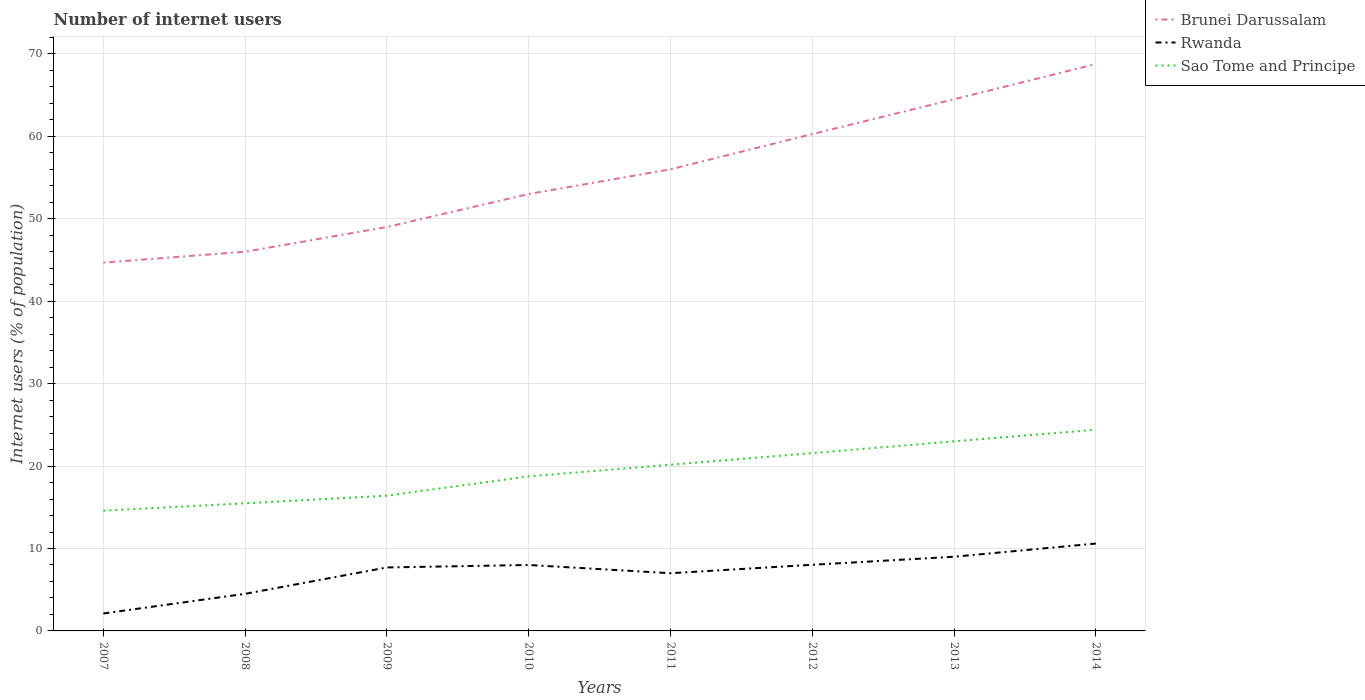How many different coloured lines are there?
Your response must be concise. 3. Does the line corresponding to Rwanda intersect with the line corresponding to Sao Tome and Principe?
Offer a terse response. No. Is the number of lines equal to the number of legend labels?
Ensure brevity in your answer.  Yes. Across all years, what is the maximum number of internet users in Brunei Darussalam?
Your response must be concise. 44.68. What is the difference between the highest and the second highest number of internet users in Sao Tome and Principe?
Provide a succinct answer. 9.82. How many lines are there?
Keep it short and to the point. 3. What is the difference between two consecutive major ticks on the Y-axis?
Your answer should be very brief. 10. How many legend labels are there?
Your answer should be compact. 3. What is the title of the graph?
Provide a succinct answer. Number of internet users. Does "Brazil" appear as one of the legend labels in the graph?
Your answer should be compact. No. What is the label or title of the Y-axis?
Provide a succinct answer. Internet users (% of population). What is the Internet users (% of population) in Brunei Darussalam in 2007?
Keep it short and to the point. 44.68. What is the Internet users (% of population) of Rwanda in 2007?
Provide a succinct answer. 2.12. What is the Internet users (% of population) in Sao Tome and Principe in 2007?
Provide a succinct answer. 14.59. What is the Internet users (% of population) in Brunei Darussalam in 2008?
Keep it short and to the point. 46. What is the Internet users (% of population) in Rwanda in 2008?
Make the answer very short. 4.5. What is the Internet users (% of population) of Sao Tome and Principe in 2008?
Your answer should be very brief. 15.48. What is the Internet users (% of population) of Brunei Darussalam in 2009?
Provide a succinct answer. 49. What is the Internet users (% of population) in Rwanda in 2009?
Your answer should be very brief. 7.7. What is the Internet users (% of population) in Sao Tome and Principe in 2009?
Provide a short and direct response. 16.41. What is the Internet users (% of population) in Brunei Darussalam in 2010?
Provide a short and direct response. 53. What is the Internet users (% of population) of Rwanda in 2010?
Ensure brevity in your answer.  8. What is the Internet users (% of population) of Sao Tome and Principe in 2010?
Your response must be concise. 18.75. What is the Internet users (% of population) of Sao Tome and Principe in 2011?
Offer a very short reply. 20.16. What is the Internet users (% of population) in Brunei Darussalam in 2012?
Make the answer very short. 60.27. What is the Internet users (% of population) in Rwanda in 2012?
Provide a succinct answer. 8.02. What is the Internet users (% of population) of Sao Tome and Principe in 2012?
Make the answer very short. 21.57. What is the Internet users (% of population) of Brunei Darussalam in 2013?
Offer a terse response. 64.5. What is the Internet users (% of population) in Brunei Darussalam in 2014?
Ensure brevity in your answer.  68.77. What is the Internet users (% of population) in Rwanda in 2014?
Make the answer very short. 10.6. What is the Internet users (% of population) of Sao Tome and Principe in 2014?
Your answer should be compact. 24.41. Across all years, what is the maximum Internet users (% of population) of Brunei Darussalam?
Give a very brief answer. 68.77. Across all years, what is the maximum Internet users (% of population) in Sao Tome and Principe?
Give a very brief answer. 24.41. Across all years, what is the minimum Internet users (% of population) of Brunei Darussalam?
Your response must be concise. 44.68. Across all years, what is the minimum Internet users (% of population) of Rwanda?
Your answer should be very brief. 2.12. Across all years, what is the minimum Internet users (% of population) of Sao Tome and Principe?
Your response must be concise. 14.59. What is the total Internet users (% of population) in Brunei Darussalam in the graph?
Keep it short and to the point. 442.22. What is the total Internet users (% of population) in Rwanda in the graph?
Give a very brief answer. 56.94. What is the total Internet users (% of population) in Sao Tome and Principe in the graph?
Offer a terse response. 154.37. What is the difference between the Internet users (% of population) of Brunei Darussalam in 2007 and that in 2008?
Keep it short and to the point. -1.32. What is the difference between the Internet users (% of population) in Rwanda in 2007 and that in 2008?
Your answer should be compact. -2.38. What is the difference between the Internet users (% of population) in Sao Tome and Principe in 2007 and that in 2008?
Offer a terse response. -0.89. What is the difference between the Internet users (% of population) in Brunei Darussalam in 2007 and that in 2009?
Offer a very short reply. -4.32. What is the difference between the Internet users (% of population) of Rwanda in 2007 and that in 2009?
Your response must be concise. -5.58. What is the difference between the Internet users (% of population) of Sao Tome and Principe in 2007 and that in 2009?
Your answer should be very brief. -1.82. What is the difference between the Internet users (% of population) of Brunei Darussalam in 2007 and that in 2010?
Offer a very short reply. -8.32. What is the difference between the Internet users (% of population) in Rwanda in 2007 and that in 2010?
Make the answer very short. -5.88. What is the difference between the Internet users (% of population) in Sao Tome and Principe in 2007 and that in 2010?
Give a very brief answer. -4.16. What is the difference between the Internet users (% of population) in Brunei Darussalam in 2007 and that in 2011?
Your response must be concise. -11.32. What is the difference between the Internet users (% of population) of Rwanda in 2007 and that in 2011?
Ensure brevity in your answer.  -4.88. What is the difference between the Internet users (% of population) of Sao Tome and Principe in 2007 and that in 2011?
Provide a succinct answer. -5.57. What is the difference between the Internet users (% of population) in Brunei Darussalam in 2007 and that in 2012?
Make the answer very short. -15.59. What is the difference between the Internet users (% of population) in Rwanda in 2007 and that in 2012?
Provide a succinct answer. -5.91. What is the difference between the Internet users (% of population) in Sao Tome and Principe in 2007 and that in 2012?
Offer a terse response. -6.98. What is the difference between the Internet users (% of population) of Brunei Darussalam in 2007 and that in 2013?
Provide a succinct answer. -19.82. What is the difference between the Internet users (% of population) in Rwanda in 2007 and that in 2013?
Offer a very short reply. -6.88. What is the difference between the Internet users (% of population) of Sao Tome and Principe in 2007 and that in 2013?
Keep it short and to the point. -8.41. What is the difference between the Internet users (% of population) in Brunei Darussalam in 2007 and that in 2014?
Ensure brevity in your answer.  -24.09. What is the difference between the Internet users (% of population) of Rwanda in 2007 and that in 2014?
Offer a very short reply. -8.48. What is the difference between the Internet users (% of population) of Sao Tome and Principe in 2007 and that in 2014?
Your answer should be compact. -9.82. What is the difference between the Internet users (% of population) of Sao Tome and Principe in 2008 and that in 2009?
Give a very brief answer. -0.93. What is the difference between the Internet users (% of population) in Brunei Darussalam in 2008 and that in 2010?
Your answer should be compact. -7. What is the difference between the Internet users (% of population) in Sao Tome and Principe in 2008 and that in 2010?
Provide a succinct answer. -3.27. What is the difference between the Internet users (% of population) of Rwanda in 2008 and that in 2011?
Your answer should be compact. -2.5. What is the difference between the Internet users (% of population) in Sao Tome and Principe in 2008 and that in 2011?
Ensure brevity in your answer.  -4.68. What is the difference between the Internet users (% of population) in Brunei Darussalam in 2008 and that in 2012?
Provide a succinct answer. -14.27. What is the difference between the Internet users (% of population) in Rwanda in 2008 and that in 2012?
Your answer should be very brief. -3.52. What is the difference between the Internet users (% of population) of Sao Tome and Principe in 2008 and that in 2012?
Keep it short and to the point. -6.09. What is the difference between the Internet users (% of population) of Brunei Darussalam in 2008 and that in 2013?
Make the answer very short. -18.5. What is the difference between the Internet users (% of population) of Rwanda in 2008 and that in 2013?
Your response must be concise. -4.5. What is the difference between the Internet users (% of population) of Sao Tome and Principe in 2008 and that in 2013?
Provide a short and direct response. -7.52. What is the difference between the Internet users (% of population) in Brunei Darussalam in 2008 and that in 2014?
Provide a short and direct response. -22.77. What is the difference between the Internet users (% of population) of Sao Tome and Principe in 2008 and that in 2014?
Provide a short and direct response. -8.93. What is the difference between the Internet users (% of population) in Brunei Darussalam in 2009 and that in 2010?
Offer a terse response. -4. What is the difference between the Internet users (% of population) of Rwanda in 2009 and that in 2010?
Your response must be concise. -0.3. What is the difference between the Internet users (% of population) in Sao Tome and Principe in 2009 and that in 2010?
Provide a short and direct response. -2.34. What is the difference between the Internet users (% of population) in Brunei Darussalam in 2009 and that in 2011?
Provide a succinct answer. -7. What is the difference between the Internet users (% of population) in Sao Tome and Principe in 2009 and that in 2011?
Your answer should be compact. -3.75. What is the difference between the Internet users (% of population) of Brunei Darussalam in 2009 and that in 2012?
Give a very brief answer. -11.27. What is the difference between the Internet users (% of population) in Rwanda in 2009 and that in 2012?
Offer a terse response. -0.32. What is the difference between the Internet users (% of population) of Sao Tome and Principe in 2009 and that in 2012?
Make the answer very short. -5.16. What is the difference between the Internet users (% of population) in Brunei Darussalam in 2009 and that in 2013?
Offer a very short reply. -15.5. What is the difference between the Internet users (% of population) in Sao Tome and Principe in 2009 and that in 2013?
Provide a short and direct response. -6.59. What is the difference between the Internet users (% of population) of Brunei Darussalam in 2009 and that in 2014?
Offer a very short reply. -19.77. What is the difference between the Internet users (% of population) in Rwanda in 2009 and that in 2014?
Your answer should be very brief. -2.9. What is the difference between the Internet users (% of population) in Brunei Darussalam in 2010 and that in 2011?
Offer a very short reply. -3. What is the difference between the Internet users (% of population) of Rwanda in 2010 and that in 2011?
Your answer should be very brief. 1. What is the difference between the Internet users (% of population) in Sao Tome and Principe in 2010 and that in 2011?
Provide a succinct answer. -1.41. What is the difference between the Internet users (% of population) in Brunei Darussalam in 2010 and that in 2012?
Give a very brief answer. -7.27. What is the difference between the Internet users (% of population) of Rwanda in 2010 and that in 2012?
Provide a short and direct response. -0.02. What is the difference between the Internet users (% of population) in Sao Tome and Principe in 2010 and that in 2012?
Offer a very short reply. -2.82. What is the difference between the Internet users (% of population) in Brunei Darussalam in 2010 and that in 2013?
Provide a short and direct response. -11.5. What is the difference between the Internet users (% of population) of Rwanda in 2010 and that in 2013?
Offer a very short reply. -1. What is the difference between the Internet users (% of population) of Sao Tome and Principe in 2010 and that in 2013?
Give a very brief answer. -4.25. What is the difference between the Internet users (% of population) in Brunei Darussalam in 2010 and that in 2014?
Keep it short and to the point. -15.77. What is the difference between the Internet users (% of population) of Sao Tome and Principe in 2010 and that in 2014?
Your answer should be compact. -5.66. What is the difference between the Internet users (% of population) in Brunei Darussalam in 2011 and that in 2012?
Your answer should be compact. -4.27. What is the difference between the Internet users (% of population) in Rwanda in 2011 and that in 2012?
Give a very brief answer. -1.02. What is the difference between the Internet users (% of population) in Sao Tome and Principe in 2011 and that in 2012?
Your response must be concise. -1.41. What is the difference between the Internet users (% of population) of Rwanda in 2011 and that in 2013?
Offer a very short reply. -2. What is the difference between the Internet users (% of population) in Sao Tome and Principe in 2011 and that in 2013?
Keep it short and to the point. -2.84. What is the difference between the Internet users (% of population) of Brunei Darussalam in 2011 and that in 2014?
Your answer should be very brief. -12.77. What is the difference between the Internet users (% of population) in Sao Tome and Principe in 2011 and that in 2014?
Ensure brevity in your answer.  -4.25. What is the difference between the Internet users (% of population) in Brunei Darussalam in 2012 and that in 2013?
Keep it short and to the point. -4.23. What is the difference between the Internet users (% of population) of Rwanda in 2012 and that in 2013?
Offer a very short reply. -0.98. What is the difference between the Internet users (% of population) in Sao Tome and Principe in 2012 and that in 2013?
Your answer should be compact. -1.43. What is the difference between the Internet users (% of population) in Brunei Darussalam in 2012 and that in 2014?
Offer a very short reply. -8.5. What is the difference between the Internet users (% of population) in Rwanda in 2012 and that in 2014?
Provide a succinct answer. -2.58. What is the difference between the Internet users (% of population) of Sao Tome and Principe in 2012 and that in 2014?
Make the answer very short. -2.84. What is the difference between the Internet users (% of population) of Brunei Darussalam in 2013 and that in 2014?
Provide a short and direct response. -4.27. What is the difference between the Internet users (% of population) in Sao Tome and Principe in 2013 and that in 2014?
Provide a short and direct response. -1.41. What is the difference between the Internet users (% of population) in Brunei Darussalam in 2007 and the Internet users (% of population) in Rwanda in 2008?
Your answer should be compact. 40.18. What is the difference between the Internet users (% of population) in Brunei Darussalam in 2007 and the Internet users (% of population) in Sao Tome and Principe in 2008?
Your answer should be compact. 29.2. What is the difference between the Internet users (% of population) of Rwanda in 2007 and the Internet users (% of population) of Sao Tome and Principe in 2008?
Provide a succinct answer. -13.36. What is the difference between the Internet users (% of population) of Brunei Darussalam in 2007 and the Internet users (% of population) of Rwanda in 2009?
Your answer should be compact. 36.98. What is the difference between the Internet users (% of population) in Brunei Darussalam in 2007 and the Internet users (% of population) in Sao Tome and Principe in 2009?
Your answer should be very brief. 28.27. What is the difference between the Internet users (% of population) in Rwanda in 2007 and the Internet users (% of population) in Sao Tome and Principe in 2009?
Provide a succinct answer. -14.29. What is the difference between the Internet users (% of population) of Brunei Darussalam in 2007 and the Internet users (% of population) of Rwanda in 2010?
Your answer should be very brief. 36.68. What is the difference between the Internet users (% of population) in Brunei Darussalam in 2007 and the Internet users (% of population) in Sao Tome and Principe in 2010?
Keep it short and to the point. 25.93. What is the difference between the Internet users (% of population) in Rwanda in 2007 and the Internet users (% of population) in Sao Tome and Principe in 2010?
Give a very brief answer. -16.63. What is the difference between the Internet users (% of population) in Brunei Darussalam in 2007 and the Internet users (% of population) in Rwanda in 2011?
Your response must be concise. 37.68. What is the difference between the Internet users (% of population) in Brunei Darussalam in 2007 and the Internet users (% of population) in Sao Tome and Principe in 2011?
Your response must be concise. 24.52. What is the difference between the Internet users (% of population) of Rwanda in 2007 and the Internet users (% of population) of Sao Tome and Principe in 2011?
Your answer should be compact. -18.05. What is the difference between the Internet users (% of population) of Brunei Darussalam in 2007 and the Internet users (% of population) of Rwanda in 2012?
Your answer should be very brief. 36.66. What is the difference between the Internet users (% of population) of Brunei Darussalam in 2007 and the Internet users (% of population) of Sao Tome and Principe in 2012?
Your answer should be compact. 23.11. What is the difference between the Internet users (% of population) in Rwanda in 2007 and the Internet users (% of population) in Sao Tome and Principe in 2012?
Offer a terse response. -19.46. What is the difference between the Internet users (% of population) of Brunei Darussalam in 2007 and the Internet users (% of population) of Rwanda in 2013?
Provide a short and direct response. 35.68. What is the difference between the Internet users (% of population) of Brunei Darussalam in 2007 and the Internet users (% of population) of Sao Tome and Principe in 2013?
Make the answer very short. 21.68. What is the difference between the Internet users (% of population) in Rwanda in 2007 and the Internet users (% of population) in Sao Tome and Principe in 2013?
Make the answer very short. -20.88. What is the difference between the Internet users (% of population) of Brunei Darussalam in 2007 and the Internet users (% of population) of Rwanda in 2014?
Your answer should be very brief. 34.08. What is the difference between the Internet users (% of population) in Brunei Darussalam in 2007 and the Internet users (% of population) in Sao Tome and Principe in 2014?
Provide a short and direct response. 20.27. What is the difference between the Internet users (% of population) in Rwanda in 2007 and the Internet users (% of population) in Sao Tome and Principe in 2014?
Offer a terse response. -22.29. What is the difference between the Internet users (% of population) of Brunei Darussalam in 2008 and the Internet users (% of population) of Rwanda in 2009?
Give a very brief answer. 38.3. What is the difference between the Internet users (% of population) of Brunei Darussalam in 2008 and the Internet users (% of population) of Sao Tome and Principe in 2009?
Make the answer very short. 29.59. What is the difference between the Internet users (% of population) of Rwanda in 2008 and the Internet users (% of population) of Sao Tome and Principe in 2009?
Make the answer very short. -11.91. What is the difference between the Internet users (% of population) of Brunei Darussalam in 2008 and the Internet users (% of population) of Sao Tome and Principe in 2010?
Provide a short and direct response. 27.25. What is the difference between the Internet users (% of population) in Rwanda in 2008 and the Internet users (% of population) in Sao Tome and Principe in 2010?
Ensure brevity in your answer.  -14.25. What is the difference between the Internet users (% of population) in Brunei Darussalam in 2008 and the Internet users (% of population) in Sao Tome and Principe in 2011?
Make the answer very short. 25.84. What is the difference between the Internet users (% of population) of Rwanda in 2008 and the Internet users (% of population) of Sao Tome and Principe in 2011?
Offer a terse response. -15.66. What is the difference between the Internet users (% of population) of Brunei Darussalam in 2008 and the Internet users (% of population) of Rwanda in 2012?
Ensure brevity in your answer.  37.98. What is the difference between the Internet users (% of population) in Brunei Darussalam in 2008 and the Internet users (% of population) in Sao Tome and Principe in 2012?
Your response must be concise. 24.43. What is the difference between the Internet users (% of population) of Rwanda in 2008 and the Internet users (% of population) of Sao Tome and Principe in 2012?
Your answer should be compact. -17.07. What is the difference between the Internet users (% of population) of Brunei Darussalam in 2008 and the Internet users (% of population) of Sao Tome and Principe in 2013?
Your answer should be compact. 23. What is the difference between the Internet users (% of population) of Rwanda in 2008 and the Internet users (% of population) of Sao Tome and Principe in 2013?
Provide a short and direct response. -18.5. What is the difference between the Internet users (% of population) of Brunei Darussalam in 2008 and the Internet users (% of population) of Rwanda in 2014?
Your answer should be compact. 35.4. What is the difference between the Internet users (% of population) of Brunei Darussalam in 2008 and the Internet users (% of population) of Sao Tome and Principe in 2014?
Keep it short and to the point. 21.59. What is the difference between the Internet users (% of population) of Rwanda in 2008 and the Internet users (% of population) of Sao Tome and Principe in 2014?
Your answer should be very brief. -19.91. What is the difference between the Internet users (% of population) of Brunei Darussalam in 2009 and the Internet users (% of population) of Sao Tome and Principe in 2010?
Offer a very short reply. 30.25. What is the difference between the Internet users (% of population) in Rwanda in 2009 and the Internet users (% of population) in Sao Tome and Principe in 2010?
Offer a terse response. -11.05. What is the difference between the Internet users (% of population) in Brunei Darussalam in 2009 and the Internet users (% of population) in Rwanda in 2011?
Offer a terse response. 42. What is the difference between the Internet users (% of population) in Brunei Darussalam in 2009 and the Internet users (% of population) in Sao Tome and Principe in 2011?
Make the answer very short. 28.84. What is the difference between the Internet users (% of population) in Rwanda in 2009 and the Internet users (% of population) in Sao Tome and Principe in 2011?
Your answer should be compact. -12.46. What is the difference between the Internet users (% of population) of Brunei Darussalam in 2009 and the Internet users (% of population) of Rwanda in 2012?
Provide a succinct answer. 40.98. What is the difference between the Internet users (% of population) in Brunei Darussalam in 2009 and the Internet users (% of population) in Sao Tome and Principe in 2012?
Offer a very short reply. 27.43. What is the difference between the Internet users (% of population) in Rwanda in 2009 and the Internet users (% of population) in Sao Tome and Principe in 2012?
Make the answer very short. -13.87. What is the difference between the Internet users (% of population) in Brunei Darussalam in 2009 and the Internet users (% of population) in Sao Tome and Principe in 2013?
Make the answer very short. 26. What is the difference between the Internet users (% of population) in Rwanda in 2009 and the Internet users (% of population) in Sao Tome and Principe in 2013?
Ensure brevity in your answer.  -15.3. What is the difference between the Internet users (% of population) in Brunei Darussalam in 2009 and the Internet users (% of population) in Rwanda in 2014?
Give a very brief answer. 38.4. What is the difference between the Internet users (% of population) of Brunei Darussalam in 2009 and the Internet users (% of population) of Sao Tome and Principe in 2014?
Provide a short and direct response. 24.59. What is the difference between the Internet users (% of population) of Rwanda in 2009 and the Internet users (% of population) of Sao Tome and Principe in 2014?
Your response must be concise. -16.71. What is the difference between the Internet users (% of population) in Brunei Darussalam in 2010 and the Internet users (% of population) in Rwanda in 2011?
Keep it short and to the point. 46. What is the difference between the Internet users (% of population) of Brunei Darussalam in 2010 and the Internet users (% of population) of Sao Tome and Principe in 2011?
Your answer should be very brief. 32.84. What is the difference between the Internet users (% of population) of Rwanda in 2010 and the Internet users (% of population) of Sao Tome and Principe in 2011?
Your answer should be compact. -12.16. What is the difference between the Internet users (% of population) in Brunei Darussalam in 2010 and the Internet users (% of population) in Rwanda in 2012?
Offer a very short reply. 44.98. What is the difference between the Internet users (% of population) in Brunei Darussalam in 2010 and the Internet users (% of population) in Sao Tome and Principe in 2012?
Ensure brevity in your answer.  31.43. What is the difference between the Internet users (% of population) of Rwanda in 2010 and the Internet users (% of population) of Sao Tome and Principe in 2012?
Provide a succinct answer. -13.57. What is the difference between the Internet users (% of population) in Brunei Darussalam in 2010 and the Internet users (% of population) in Sao Tome and Principe in 2013?
Provide a succinct answer. 30. What is the difference between the Internet users (% of population) of Brunei Darussalam in 2010 and the Internet users (% of population) of Rwanda in 2014?
Your answer should be very brief. 42.4. What is the difference between the Internet users (% of population) in Brunei Darussalam in 2010 and the Internet users (% of population) in Sao Tome and Principe in 2014?
Make the answer very short. 28.59. What is the difference between the Internet users (% of population) in Rwanda in 2010 and the Internet users (% of population) in Sao Tome and Principe in 2014?
Offer a very short reply. -16.41. What is the difference between the Internet users (% of population) in Brunei Darussalam in 2011 and the Internet users (% of population) in Rwanda in 2012?
Provide a short and direct response. 47.98. What is the difference between the Internet users (% of population) in Brunei Darussalam in 2011 and the Internet users (% of population) in Sao Tome and Principe in 2012?
Your response must be concise. 34.43. What is the difference between the Internet users (% of population) of Rwanda in 2011 and the Internet users (% of population) of Sao Tome and Principe in 2012?
Make the answer very short. -14.57. What is the difference between the Internet users (% of population) in Brunei Darussalam in 2011 and the Internet users (% of population) in Rwanda in 2013?
Your response must be concise. 47. What is the difference between the Internet users (% of population) in Brunei Darussalam in 2011 and the Internet users (% of population) in Sao Tome and Principe in 2013?
Your response must be concise. 33. What is the difference between the Internet users (% of population) in Rwanda in 2011 and the Internet users (% of population) in Sao Tome and Principe in 2013?
Provide a short and direct response. -16. What is the difference between the Internet users (% of population) in Brunei Darussalam in 2011 and the Internet users (% of population) in Rwanda in 2014?
Offer a very short reply. 45.4. What is the difference between the Internet users (% of population) in Brunei Darussalam in 2011 and the Internet users (% of population) in Sao Tome and Principe in 2014?
Your response must be concise. 31.59. What is the difference between the Internet users (% of population) of Rwanda in 2011 and the Internet users (% of population) of Sao Tome and Principe in 2014?
Give a very brief answer. -17.41. What is the difference between the Internet users (% of population) of Brunei Darussalam in 2012 and the Internet users (% of population) of Rwanda in 2013?
Provide a succinct answer. 51.27. What is the difference between the Internet users (% of population) of Brunei Darussalam in 2012 and the Internet users (% of population) of Sao Tome and Principe in 2013?
Provide a succinct answer. 37.27. What is the difference between the Internet users (% of population) of Rwanda in 2012 and the Internet users (% of population) of Sao Tome and Principe in 2013?
Offer a terse response. -14.98. What is the difference between the Internet users (% of population) of Brunei Darussalam in 2012 and the Internet users (% of population) of Rwanda in 2014?
Make the answer very short. 49.67. What is the difference between the Internet users (% of population) of Brunei Darussalam in 2012 and the Internet users (% of population) of Sao Tome and Principe in 2014?
Ensure brevity in your answer.  35.86. What is the difference between the Internet users (% of population) in Rwanda in 2012 and the Internet users (% of population) in Sao Tome and Principe in 2014?
Your answer should be very brief. -16.39. What is the difference between the Internet users (% of population) of Brunei Darussalam in 2013 and the Internet users (% of population) of Rwanda in 2014?
Ensure brevity in your answer.  53.9. What is the difference between the Internet users (% of population) in Brunei Darussalam in 2013 and the Internet users (% of population) in Sao Tome and Principe in 2014?
Your answer should be compact. 40.09. What is the difference between the Internet users (% of population) of Rwanda in 2013 and the Internet users (% of population) of Sao Tome and Principe in 2014?
Ensure brevity in your answer.  -15.41. What is the average Internet users (% of population) in Brunei Darussalam per year?
Provide a short and direct response. 55.28. What is the average Internet users (% of population) of Rwanda per year?
Make the answer very short. 7.12. What is the average Internet users (% of population) in Sao Tome and Principe per year?
Offer a very short reply. 19.3. In the year 2007, what is the difference between the Internet users (% of population) of Brunei Darussalam and Internet users (% of population) of Rwanda?
Offer a very short reply. 42.56. In the year 2007, what is the difference between the Internet users (% of population) in Brunei Darussalam and Internet users (% of population) in Sao Tome and Principe?
Your answer should be compact. 30.09. In the year 2007, what is the difference between the Internet users (% of population) of Rwanda and Internet users (% of population) of Sao Tome and Principe?
Make the answer very short. -12.48. In the year 2008, what is the difference between the Internet users (% of population) in Brunei Darussalam and Internet users (% of population) in Rwanda?
Provide a succinct answer. 41.5. In the year 2008, what is the difference between the Internet users (% of population) of Brunei Darussalam and Internet users (% of population) of Sao Tome and Principe?
Your response must be concise. 30.52. In the year 2008, what is the difference between the Internet users (% of population) of Rwanda and Internet users (% of population) of Sao Tome and Principe?
Your response must be concise. -10.98. In the year 2009, what is the difference between the Internet users (% of population) in Brunei Darussalam and Internet users (% of population) in Rwanda?
Offer a terse response. 41.3. In the year 2009, what is the difference between the Internet users (% of population) in Brunei Darussalam and Internet users (% of population) in Sao Tome and Principe?
Your answer should be compact. 32.59. In the year 2009, what is the difference between the Internet users (% of population) in Rwanda and Internet users (% of population) in Sao Tome and Principe?
Keep it short and to the point. -8.71. In the year 2010, what is the difference between the Internet users (% of population) in Brunei Darussalam and Internet users (% of population) in Rwanda?
Make the answer very short. 45. In the year 2010, what is the difference between the Internet users (% of population) in Brunei Darussalam and Internet users (% of population) in Sao Tome and Principe?
Offer a terse response. 34.25. In the year 2010, what is the difference between the Internet users (% of population) of Rwanda and Internet users (% of population) of Sao Tome and Principe?
Provide a short and direct response. -10.75. In the year 2011, what is the difference between the Internet users (% of population) in Brunei Darussalam and Internet users (% of population) in Rwanda?
Make the answer very short. 49. In the year 2011, what is the difference between the Internet users (% of population) of Brunei Darussalam and Internet users (% of population) of Sao Tome and Principe?
Your answer should be very brief. 35.84. In the year 2011, what is the difference between the Internet users (% of population) in Rwanda and Internet users (% of population) in Sao Tome and Principe?
Make the answer very short. -13.16. In the year 2012, what is the difference between the Internet users (% of population) in Brunei Darussalam and Internet users (% of population) in Rwanda?
Offer a terse response. 52.25. In the year 2012, what is the difference between the Internet users (% of population) of Brunei Darussalam and Internet users (% of population) of Sao Tome and Principe?
Ensure brevity in your answer.  38.7. In the year 2012, what is the difference between the Internet users (% of population) in Rwanda and Internet users (% of population) in Sao Tome and Principe?
Your answer should be compact. -13.55. In the year 2013, what is the difference between the Internet users (% of population) in Brunei Darussalam and Internet users (% of population) in Rwanda?
Offer a very short reply. 55.5. In the year 2013, what is the difference between the Internet users (% of population) of Brunei Darussalam and Internet users (% of population) of Sao Tome and Principe?
Provide a succinct answer. 41.5. In the year 2014, what is the difference between the Internet users (% of population) in Brunei Darussalam and Internet users (% of population) in Rwanda?
Offer a terse response. 58.17. In the year 2014, what is the difference between the Internet users (% of population) in Brunei Darussalam and Internet users (% of population) in Sao Tome and Principe?
Your answer should be compact. 44.36. In the year 2014, what is the difference between the Internet users (% of population) of Rwanda and Internet users (% of population) of Sao Tome and Principe?
Ensure brevity in your answer.  -13.81. What is the ratio of the Internet users (% of population) in Brunei Darussalam in 2007 to that in 2008?
Keep it short and to the point. 0.97. What is the ratio of the Internet users (% of population) in Rwanda in 2007 to that in 2008?
Your response must be concise. 0.47. What is the ratio of the Internet users (% of population) of Sao Tome and Principe in 2007 to that in 2008?
Provide a short and direct response. 0.94. What is the ratio of the Internet users (% of population) of Brunei Darussalam in 2007 to that in 2009?
Keep it short and to the point. 0.91. What is the ratio of the Internet users (% of population) in Rwanda in 2007 to that in 2009?
Provide a short and direct response. 0.27. What is the ratio of the Internet users (% of population) of Sao Tome and Principe in 2007 to that in 2009?
Ensure brevity in your answer.  0.89. What is the ratio of the Internet users (% of population) of Brunei Darussalam in 2007 to that in 2010?
Ensure brevity in your answer.  0.84. What is the ratio of the Internet users (% of population) of Rwanda in 2007 to that in 2010?
Your answer should be very brief. 0.26. What is the ratio of the Internet users (% of population) in Sao Tome and Principe in 2007 to that in 2010?
Your answer should be very brief. 0.78. What is the ratio of the Internet users (% of population) in Brunei Darussalam in 2007 to that in 2011?
Provide a short and direct response. 0.8. What is the ratio of the Internet users (% of population) of Rwanda in 2007 to that in 2011?
Provide a short and direct response. 0.3. What is the ratio of the Internet users (% of population) of Sao Tome and Principe in 2007 to that in 2011?
Provide a short and direct response. 0.72. What is the ratio of the Internet users (% of population) in Brunei Darussalam in 2007 to that in 2012?
Your answer should be compact. 0.74. What is the ratio of the Internet users (% of population) of Rwanda in 2007 to that in 2012?
Your response must be concise. 0.26. What is the ratio of the Internet users (% of population) in Sao Tome and Principe in 2007 to that in 2012?
Provide a succinct answer. 0.68. What is the ratio of the Internet users (% of population) in Brunei Darussalam in 2007 to that in 2013?
Your answer should be very brief. 0.69. What is the ratio of the Internet users (% of population) in Rwanda in 2007 to that in 2013?
Your response must be concise. 0.23. What is the ratio of the Internet users (% of population) in Sao Tome and Principe in 2007 to that in 2013?
Give a very brief answer. 0.63. What is the ratio of the Internet users (% of population) in Brunei Darussalam in 2007 to that in 2014?
Provide a short and direct response. 0.65. What is the ratio of the Internet users (% of population) in Rwanda in 2007 to that in 2014?
Give a very brief answer. 0.2. What is the ratio of the Internet users (% of population) of Sao Tome and Principe in 2007 to that in 2014?
Keep it short and to the point. 0.6. What is the ratio of the Internet users (% of population) in Brunei Darussalam in 2008 to that in 2009?
Offer a very short reply. 0.94. What is the ratio of the Internet users (% of population) of Rwanda in 2008 to that in 2009?
Provide a succinct answer. 0.58. What is the ratio of the Internet users (% of population) in Sao Tome and Principe in 2008 to that in 2009?
Provide a short and direct response. 0.94. What is the ratio of the Internet users (% of population) of Brunei Darussalam in 2008 to that in 2010?
Provide a succinct answer. 0.87. What is the ratio of the Internet users (% of population) in Rwanda in 2008 to that in 2010?
Your answer should be very brief. 0.56. What is the ratio of the Internet users (% of population) in Sao Tome and Principe in 2008 to that in 2010?
Ensure brevity in your answer.  0.83. What is the ratio of the Internet users (% of population) of Brunei Darussalam in 2008 to that in 2011?
Your answer should be very brief. 0.82. What is the ratio of the Internet users (% of population) of Rwanda in 2008 to that in 2011?
Your answer should be very brief. 0.64. What is the ratio of the Internet users (% of population) of Sao Tome and Principe in 2008 to that in 2011?
Offer a very short reply. 0.77. What is the ratio of the Internet users (% of population) in Brunei Darussalam in 2008 to that in 2012?
Keep it short and to the point. 0.76. What is the ratio of the Internet users (% of population) of Rwanda in 2008 to that in 2012?
Your answer should be compact. 0.56. What is the ratio of the Internet users (% of population) in Sao Tome and Principe in 2008 to that in 2012?
Provide a succinct answer. 0.72. What is the ratio of the Internet users (% of population) of Brunei Darussalam in 2008 to that in 2013?
Provide a succinct answer. 0.71. What is the ratio of the Internet users (% of population) of Rwanda in 2008 to that in 2013?
Your answer should be very brief. 0.5. What is the ratio of the Internet users (% of population) of Sao Tome and Principe in 2008 to that in 2013?
Your response must be concise. 0.67. What is the ratio of the Internet users (% of population) in Brunei Darussalam in 2008 to that in 2014?
Give a very brief answer. 0.67. What is the ratio of the Internet users (% of population) in Rwanda in 2008 to that in 2014?
Your answer should be compact. 0.42. What is the ratio of the Internet users (% of population) of Sao Tome and Principe in 2008 to that in 2014?
Offer a terse response. 0.63. What is the ratio of the Internet users (% of population) of Brunei Darussalam in 2009 to that in 2010?
Make the answer very short. 0.92. What is the ratio of the Internet users (% of population) in Rwanda in 2009 to that in 2010?
Give a very brief answer. 0.96. What is the ratio of the Internet users (% of population) in Sao Tome and Principe in 2009 to that in 2010?
Keep it short and to the point. 0.88. What is the ratio of the Internet users (% of population) in Sao Tome and Principe in 2009 to that in 2011?
Your answer should be very brief. 0.81. What is the ratio of the Internet users (% of population) of Brunei Darussalam in 2009 to that in 2012?
Ensure brevity in your answer.  0.81. What is the ratio of the Internet users (% of population) of Rwanda in 2009 to that in 2012?
Your response must be concise. 0.96. What is the ratio of the Internet users (% of population) of Sao Tome and Principe in 2009 to that in 2012?
Offer a very short reply. 0.76. What is the ratio of the Internet users (% of population) in Brunei Darussalam in 2009 to that in 2013?
Your answer should be very brief. 0.76. What is the ratio of the Internet users (% of population) of Rwanda in 2009 to that in 2013?
Offer a very short reply. 0.86. What is the ratio of the Internet users (% of population) in Sao Tome and Principe in 2009 to that in 2013?
Provide a short and direct response. 0.71. What is the ratio of the Internet users (% of population) of Brunei Darussalam in 2009 to that in 2014?
Provide a succinct answer. 0.71. What is the ratio of the Internet users (% of population) of Rwanda in 2009 to that in 2014?
Your response must be concise. 0.73. What is the ratio of the Internet users (% of population) of Sao Tome and Principe in 2009 to that in 2014?
Give a very brief answer. 0.67. What is the ratio of the Internet users (% of population) in Brunei Darussalam in 2010 to that in 2011?
Make the answer very short. 0.95. What is the ratio of the Internet users (% of population) of Rwanda in 2010 to that in 2011?
Ensure brevity in your answer.  1.14. What is the ratio of the Internet users (% of population) in Sao Tome and Principe in 2010 to that in 2011?
Give a very brief answer. 0.93. What is the ratio of the Internet users (% of population) of Brunei Darussalam in 2010 to that in 2012?
Your answer should be compact. 0.88. What is the ratio of the Internet users (% of population) of Rwanda in 2010 to that in 2012?
Keep it short and to the point. 1. What is the ratio of the Internet users (% of population) of Sao Tome and Principe in 2010 to that in 2012?
Offer a very short reply. 0.87. What is the ratio of the Internet users (% of population) of Brunei Darussalam in 2010 to that in 2013?
Give a very brief answer. 0.82. What is the ratio of the Internet users (% of population) of Rwanda in 2010 to that in 2013?
Your answer should be compact. 0.89. What is the ratio of the Internet users (% of population) of Sao Tome and Principe in 2010 to that in 2013?
Make the answer very short. 0.82. What is the ratio of the Internet users (% of population) in Brunei Darussalam in 2010 to that in 2014?
Provide a succinct answer. 0.77. What is the ratio of the Internet users (% of population) in Rwanda in 2010 to that in 2014?
Your answer should be compact. 0.75. What is the ratio of the Internet users (% of population) in Sao Tome and Principe in 2010 to that in 2014?
Provide a short and direct response. 0.77. What is the ratio of the Internet users (% of population) of Brunei Darussalam in 2011 to that in 2012?
Keep it short and to the point. 0.93. What is the ratio of the Internet users (% of population) in Rwanda in 2011 to that in 2012?
Make the answer very short. 0.87. What is the ratio of the Internet users (% of population) of Sao Tome and Principe in 2011 to that in 2012?
Provide a succinct answer. 0.93. What is the ratio of the Internet users (% of population) of Brunei Darussalam in 2011 to that in 2013?
Offer a very short reply. 0.87. What is the ratio of the Internet users (% of population) of Rwanda in 2011 to that in 2013?
Provide a short and direct response. 0.78. What is the ratio of the Internet users (% of population) of Sao Tome and Principe in 2011 to that in 2013?
Your answer should be compact. 0.88. What is the ratio of the Internet users (% of population) of Brunei Darussalam in 2011 to that in 2014?
Make the answer very short. 0.81. What is the ratio of the Internet users (% of population) in Rwanda in 2011 to that in 2014?
Make the answer very short. 0.66. What is the ratio of the Internet users (% of population) in Sao Tome and Principe in 2011 to that in 2014?
Offer a very short reply. 0.83. What is the ratio of the Internet users (% of population) in Brunei Darussalam in 2012 to that in 2013?
Your response must be concise. 0.93. What is the ratio of the Internet users (% of population) of Rwanda in 2012 to that in 2013?
Your response must be concise. 0.89. What is the ratio of the Internet users (% of population) in Sao Tome and Principe in 2012 to that in 2013?
Give a very brief answer. 0.94. What is the ratio of the Internet users (% of population) of Brunei Darussalam in 2012 to that in 2014?
Make the answer very short. 0.88. What is the ratio of the Internet users (% of population) of Rwanda in 2012 to that in 2014?
Provide a succinct answer. 0.76. What is the ratio of the Internet users (% of population) in Sao Tome and Principe in 2012 to that in 2014?
Your response must be concise. 0.88. What is the ratio of the Internet users (% of population) of Brunei Darussalam in 2013 to that in 2014?
Your answer should be compact. 0.94. What is the ratio of the Internet users (% of population) of Rwanda in 2013 to that in 2014?
Provide a short and direct response. 0.85. What is the ratio of the Internet users (% of population) in Sao Tome and Principe in 2013 to that in 2014?
Keep it short and to the point. 0.94. What is the difference between the highest and the second highest Internet users (% of population) in Brunei Darussalam?
Your answer should be very brief. 4.27. What is the difference between the highest and the second highest Internet users (% of population) of Rwanda?
Your answer should be very brief. 1.6. What is the difference between the highest and the second highest Internet users (% of population) of Sao Tome and Principe?
Give a very brief answer. 1.41. What is the difference between the highest and the lowest Internet users (% of population) of Brunei Darussalam?
Your answer should be compact. 24.09. What is the difference between the highest and the lowest Internet users (% of population) of Rwanda?
Offer a very short reply. 8.48. What is the difference between the highest and the lowest Internet users (% of population) of Sao Tome and Principe?
Ensure brevity in your answer.  9.82. 